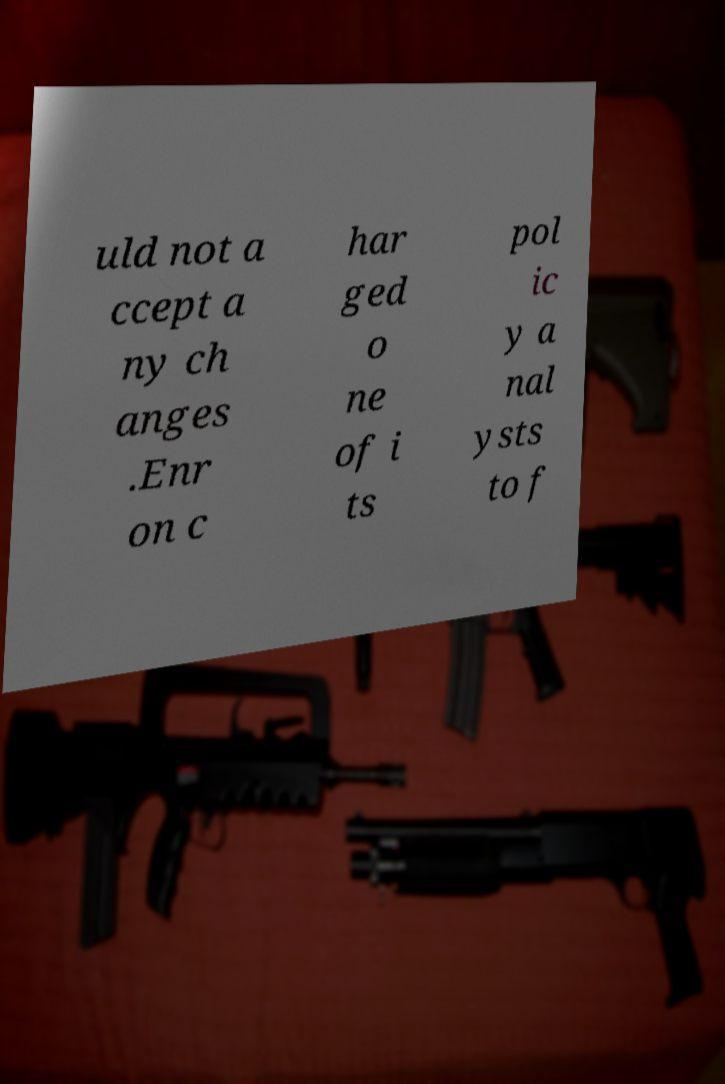There's text embedded in this image that I need extracted. Can you transcribe it verbatim? uld not a ccept a ny ch anges .Enr on c har ged o ne of i ts pol ic y a nal ysts to f 